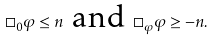Convert formula to latex. <formula><loc_0><loc_0><loc_500><loc_500>\Box _ { 0 } \varphi \leq n \ \text {and} \ \Box _ { \varphi } \varphi \geq - n .</formula> 